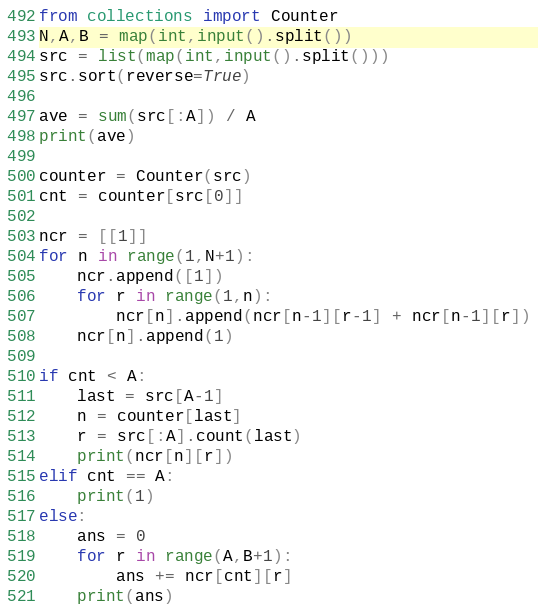<code> <loc_0><loc_0><loc_500><loc_500><_Python_>from collections import Counter
N,A,B = map(int,input().split())
src = list(map(int,input().split()))
src.sort(reverse=True)

ave = sum(src[:A]) / A
print(ave)

counter = Counter(src)
cnt = counter[src[0]]

ncr = [[1]]
for n in range(1,N+1):
    ncr.append([1])
    for r in range(1,n):
        ncr[n].append(ncr[n-1][r-1] + ncr[n-1][r])
    ncr[n].append(1)

if cnt < A:
    last = src[A-1]
    n = counter[last]
    r = src[:A].count(last)
    print(ncr[n][r])
elif cnt == A:
    print(1)
else:
    ans = 0
    for r in range(A,B+1):
        ans += ncr[cnt][r]
    print(ans)
</code> 